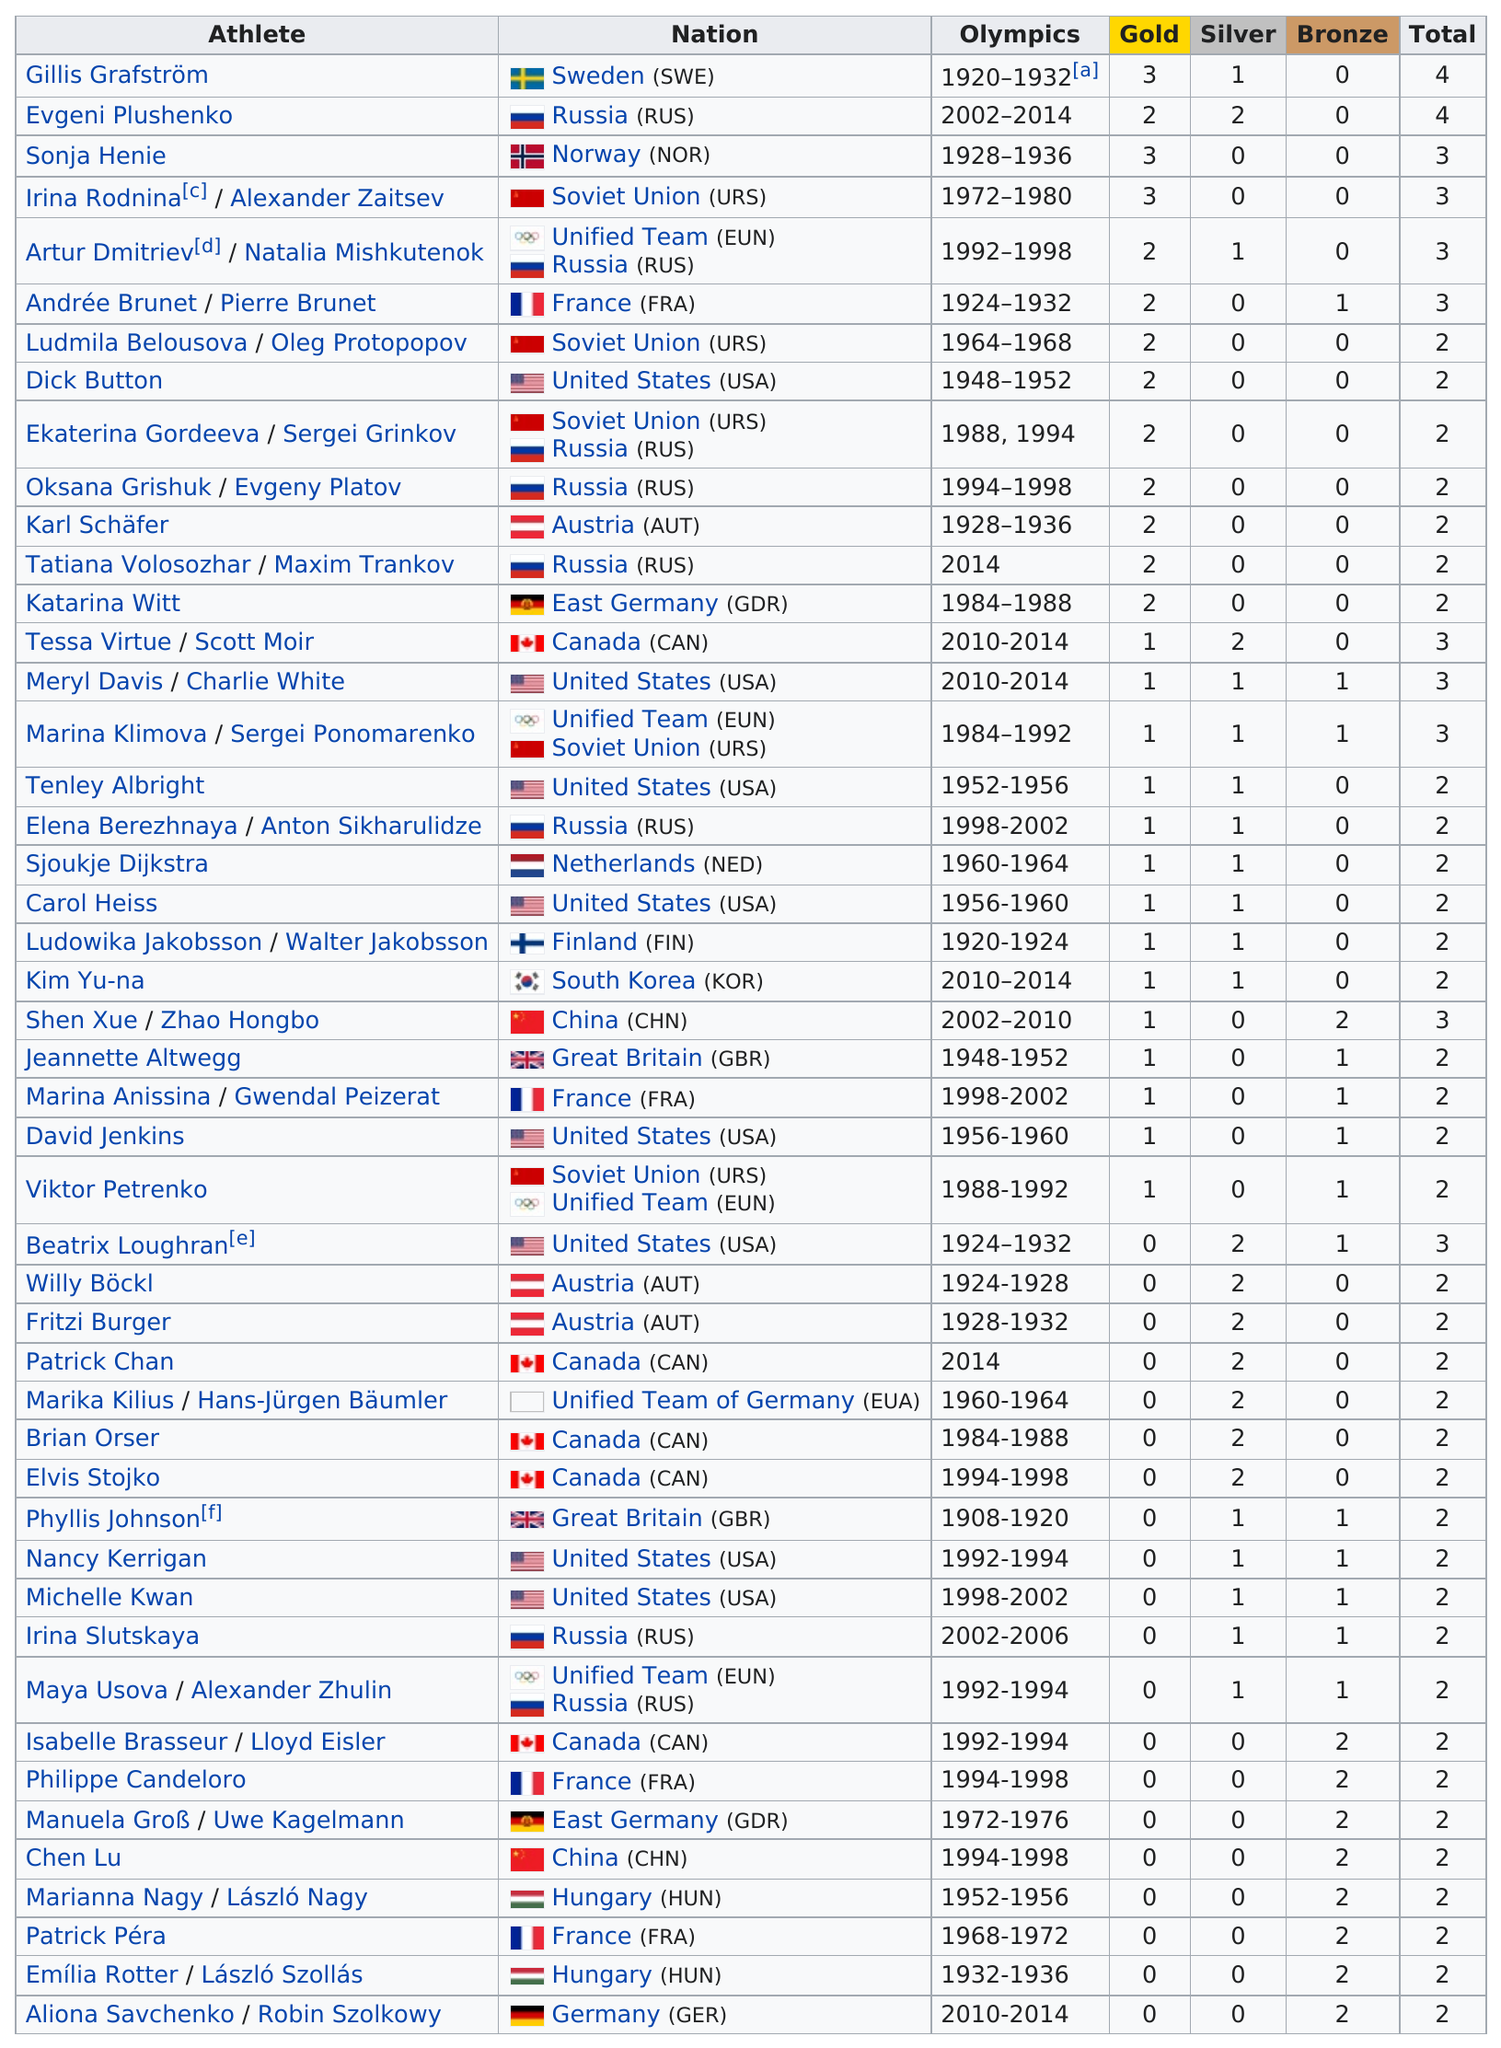Indicate a few pertinent items in this graphic. Sonja Henie was the only Norwegian woman to win a gold medal in women's ice skating. Gillis Grafström had more silver medals than Sonja Henie. The athlete who was from South Korea after the year 2010 and won many accolades is Kim Yu-na. Sweden and Norway have won a combined total of 7 medals. The greatest number of gold medals won by a single athlete was three. 